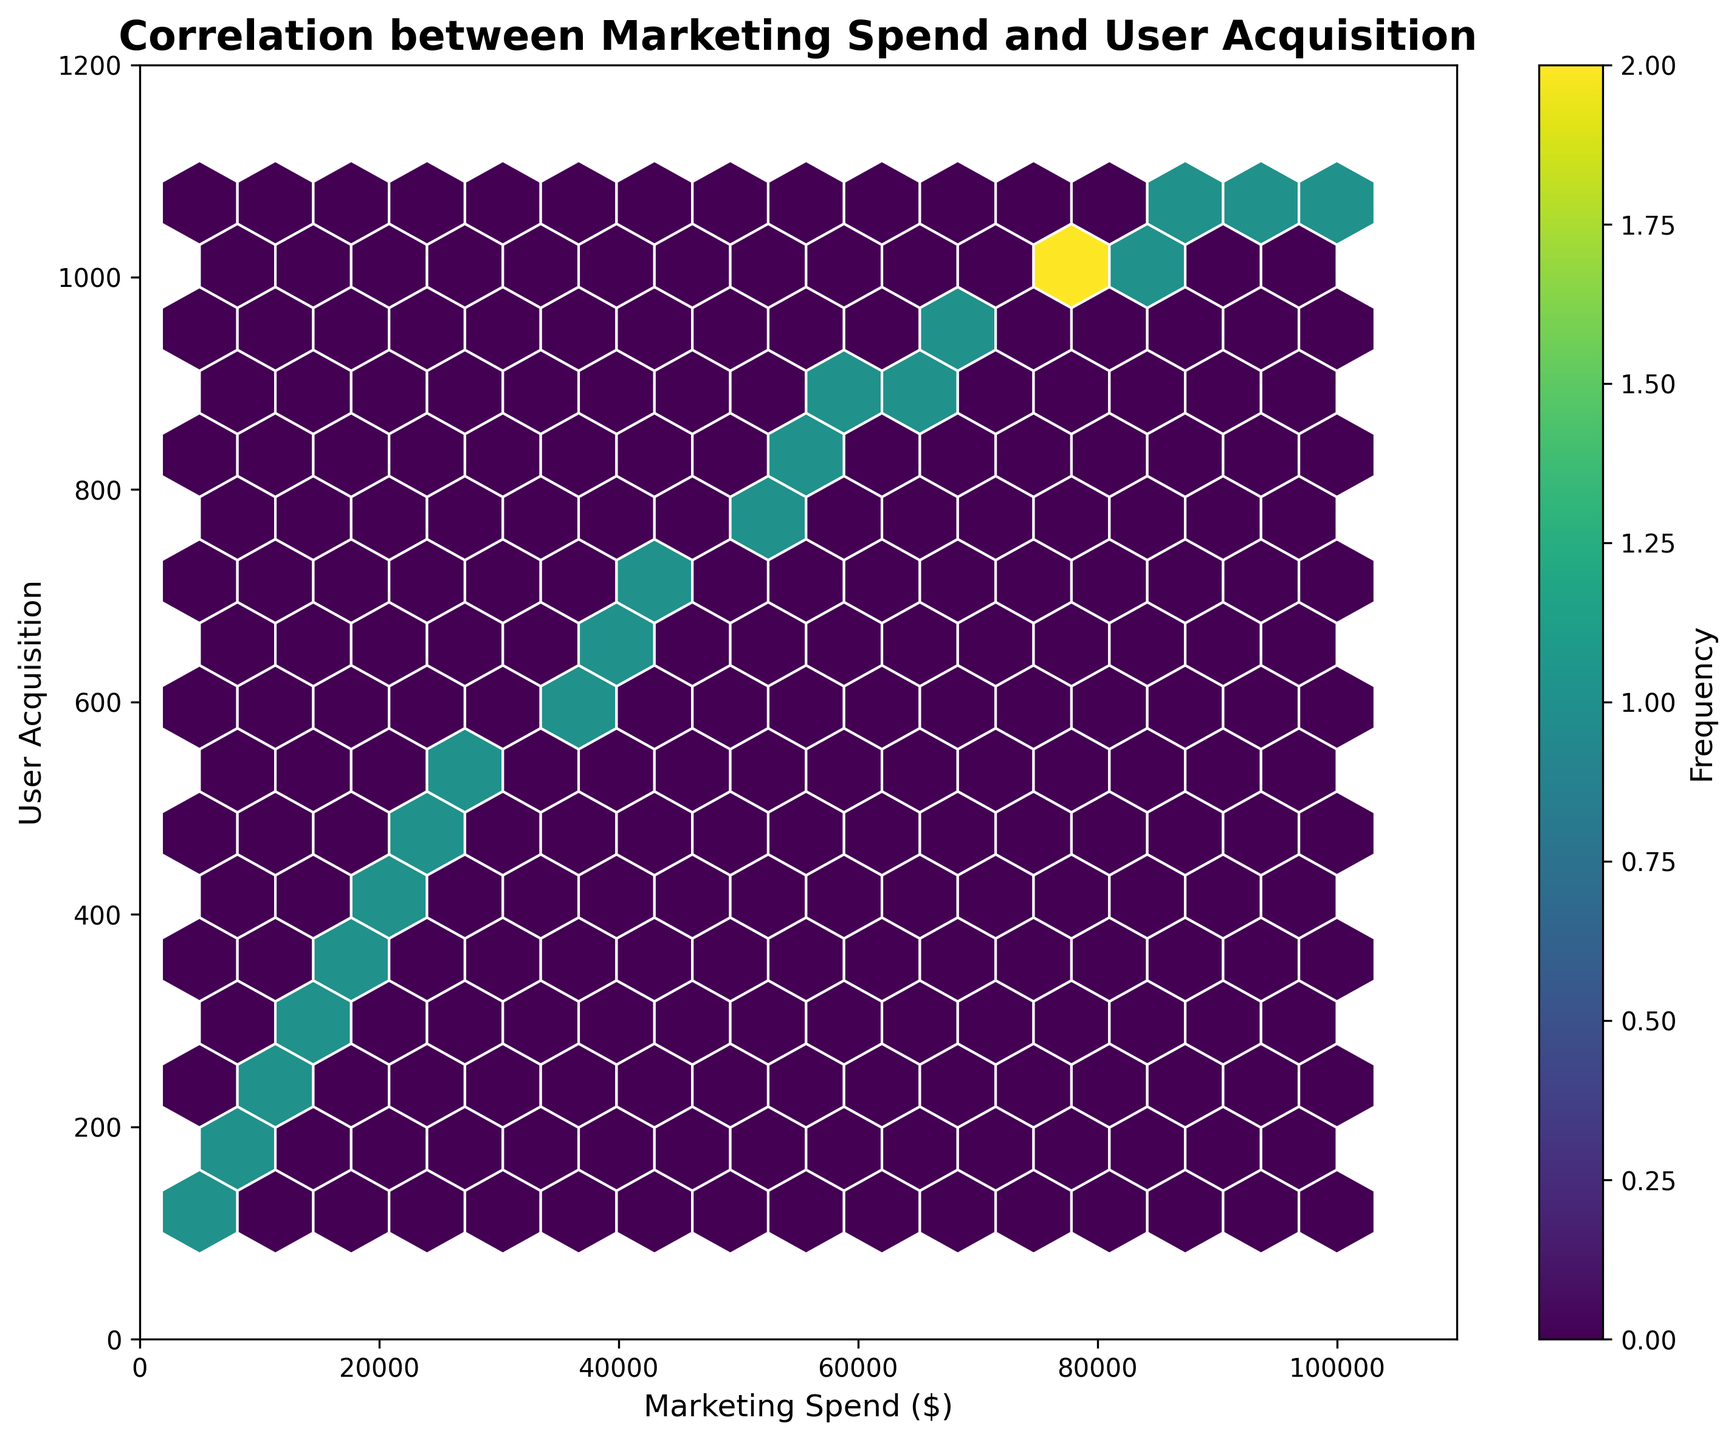What is the title of the plot? The title of the plot is written above the hexbin plot. It should be in bold font and easy to spot.
Answer: Correlation between Marketing Spend and User Acquisition What is the range of the Marketing Spend axis? The range of the Marketing Spend axis can be seen on the x-axis. The starting point is the minimum value, and the ending point is the maximum value.
Answer: 0 to 110000 What colors are used in the hexbin plot? The colors used are shown in the hexagons within the plot and also represented in the color bar on the side.
Answer: Various shades of viridis (green to yellow) How many data points are there in total? Each hexagon represents the frequency of data points in that area. The more hexagons, the more data points there are.
Answer: 22 What marketing spend amount corresponds to the highest frequency of user acquisition? Looking at the color bar and identifying the darkest hexagon(s) on the plot will show the area with the highest frequency.
Answer: Around $50000 to $75000 Is there an evident correlation between marketing spend and user acquisition? By observing if there's a general trend or pattern that appears in the plot, such as a diagonal concentration of points.
Answer: Yes Between $40000 and $60000 marketing spend, how does user acquisition change? Observe the density and spread of the hexagons plotted between $40000 and $60000 on the x-axis.
Answer: It increases noticeably Which area has the highest user acquisition per unit marketing spend increment? Identify which section of the slope has the steepest rise in the y-axis for a given x-axis interval. This will tell where user acquisition increases the most per dollar spent.
Answer: Between $60000 and $90000 Do more users get acquired for lower marketing spends or higher marketing spends? Look at the spread of the hexagons along the y-axis for the respective ranges of the x-axis values.
Answer: Higher marketing spends What is the lowest marketing spend observed in the plot, and how many users are acquired at that point? Locate the leftmost hexagon on the x-axis and see its corresponding y-axis value.
Answer: $5000; 120 users 